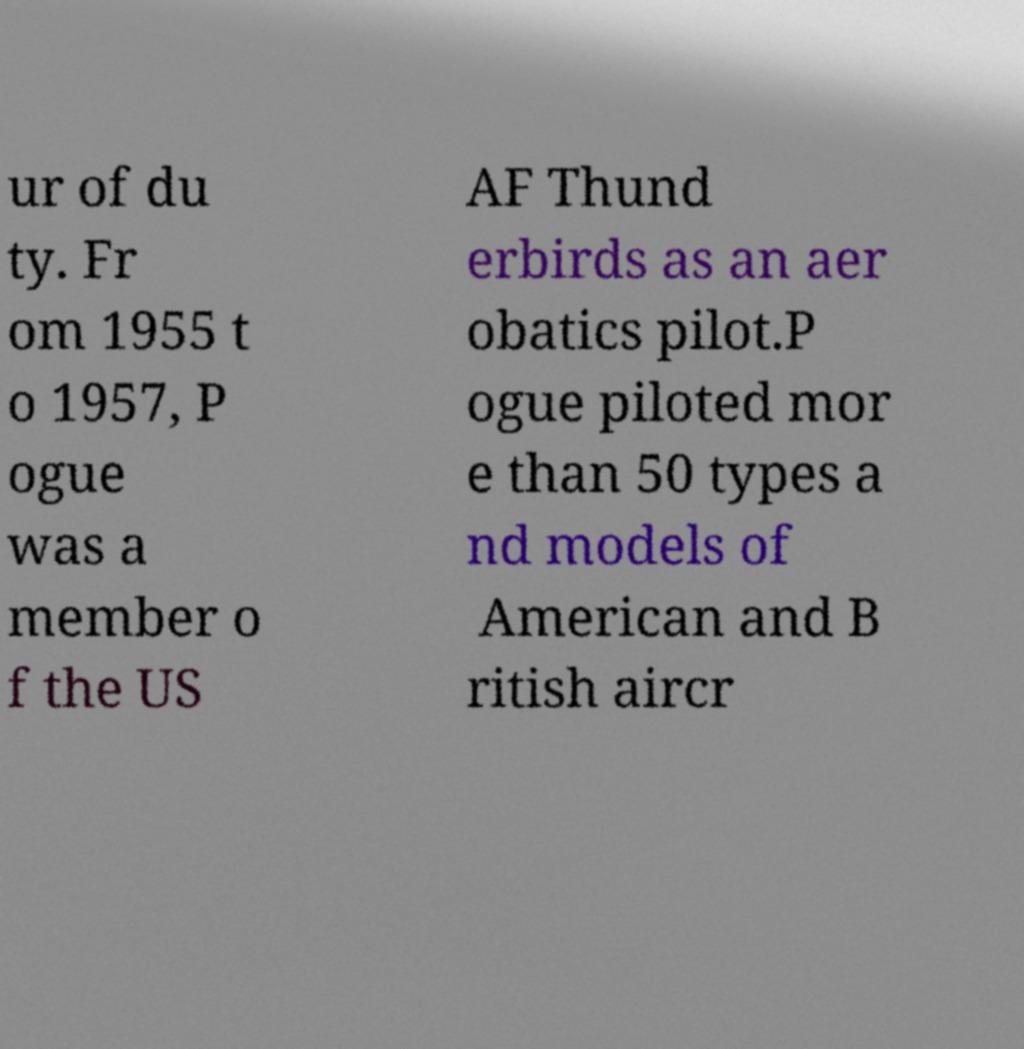Please identify and transcribe the text found in this image. ur of du ty. Fr om 1955 t o 1957, P ogue was a member o f the US AF Thund erbirds as an aer obatics pilot.P ogue piloted mor e than 50 types a nd models of American and B ritish aircr 